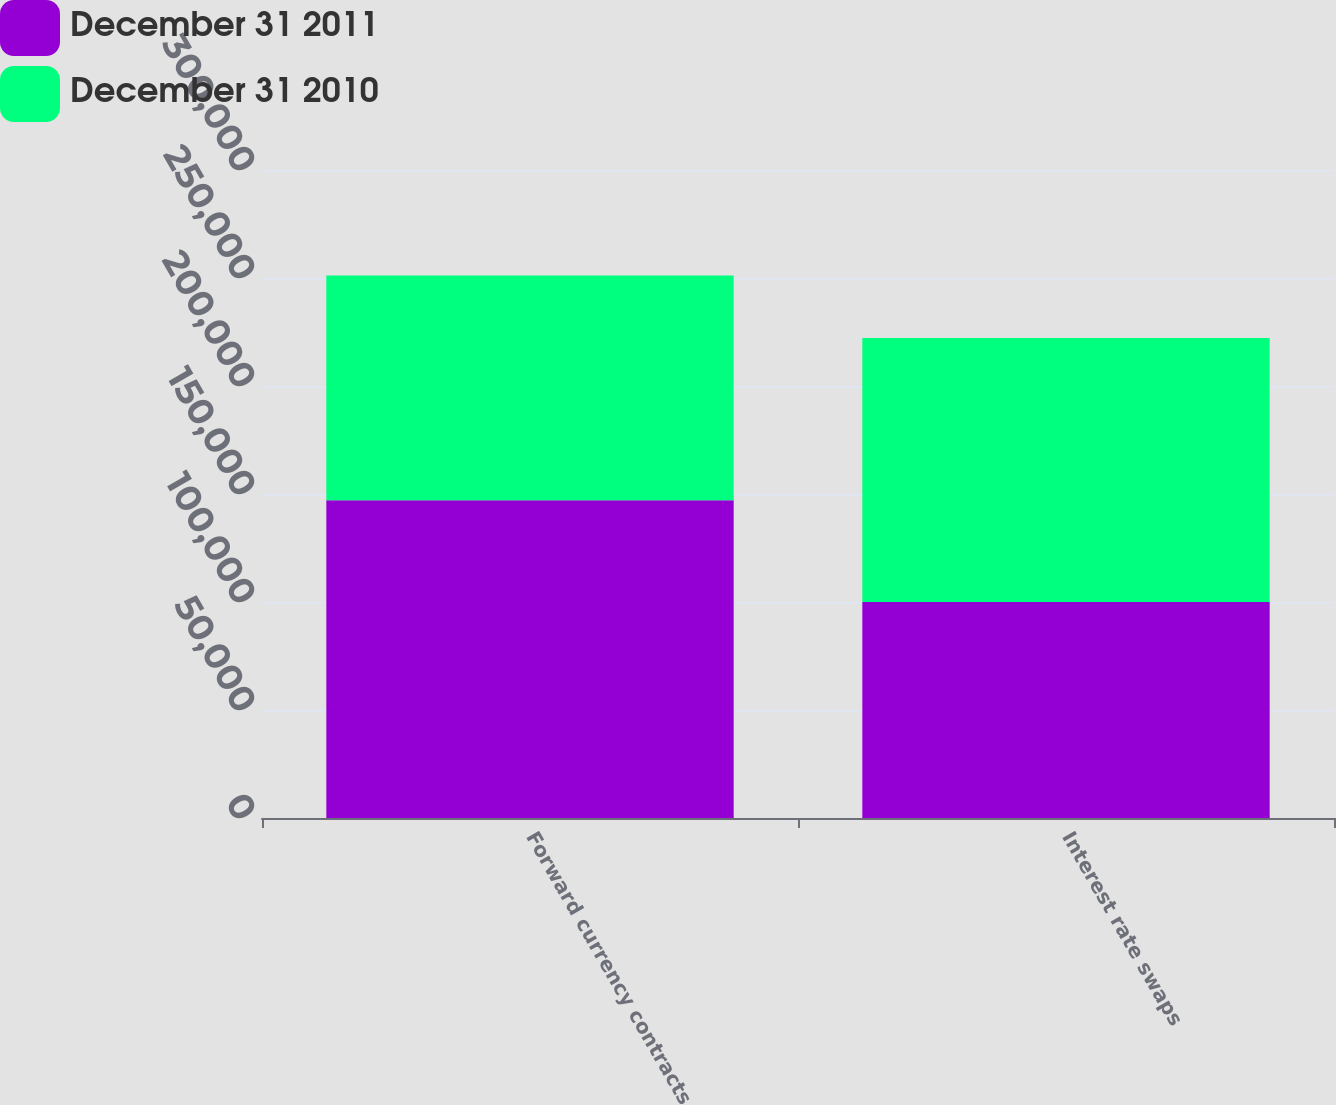Convert chart to OTSL. <chart><loc_0><loc_0><loc_500><loc_500><stacked_bar_chart><ecel><fcel>Forward currency contracts<fcel>Interest rate swaps<nl><fcel>December 31 2011<fcel>147078<fcel>100000<nl><fcel>December 31 2010<fcel>104108<fcel>122274<nl></chart> 